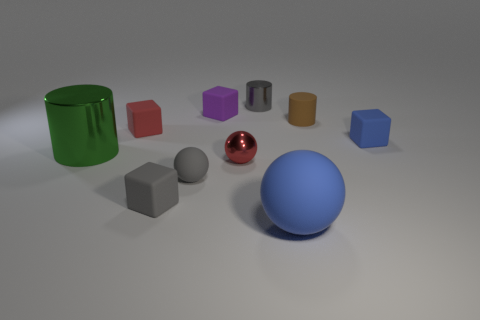Is there any other thing that has the same size as the red rubber thing?
Your response must be concise. Yes. There is a green metal object that is in front of the purple matte object; what shape is it?
Give a very brief answer. Cylinder. What number of small red things are the same shape as the big blue rubber object?
Your answer should be compact. 1. Are there an equal number of tiny gray balls in front of the large ball and green metallic cylinders behind the brown matte cylinder?
Ensure brevity in your answer.  Yes. Are there any tiny brown cylinders made of the same material as the small blue cube?
Keep it short and to the point. Yes. Do the tiny gray cylinder and the blue ball have the same material?
Your response must be concise. No. What number of gray objects are matte balls or big rubber objects?
Offer a terse response. 1. Is the number of small gray cylinders that are behind the tiny blue thing greater than the number of gray matte cylinders?
Provide a short and direct response. Yes. Is there a rubber ball that has the same color as the shiny sphere?
Your answer should be compact. No. How big is the brown cylinder?
Ensure brevity in your answer.  Small. 